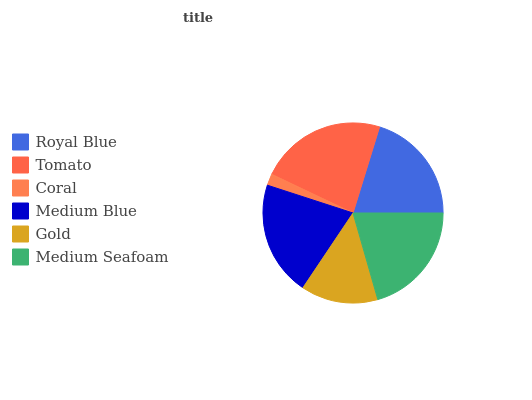Is Coral the minimum?
Answer yes or no. Yes. Is Tomato the maximum?
Answer yes or no. Yes. Is Tomato the minimum?
Answer yes or no. No. Is Coral the maximum?
Answer yes or no. No. Is Tomato greater than Coral?
Answer yes or no. Yes. Is Coral less than Tomato?
Answer yes or no. Yes. Is Coral greater than Tomato?
Answer yes or no. No. Is Tomato less than Coral?
Answer yes or no. No. Is Medium Seafoam the high median?
Answer yes or no. Yes. Is Royal Blue the low median?
Answer yes or no. Yes. Is Gold the high median?
Answer yes or no. No. Is Gold the low median?
Answer yes or no. No. 